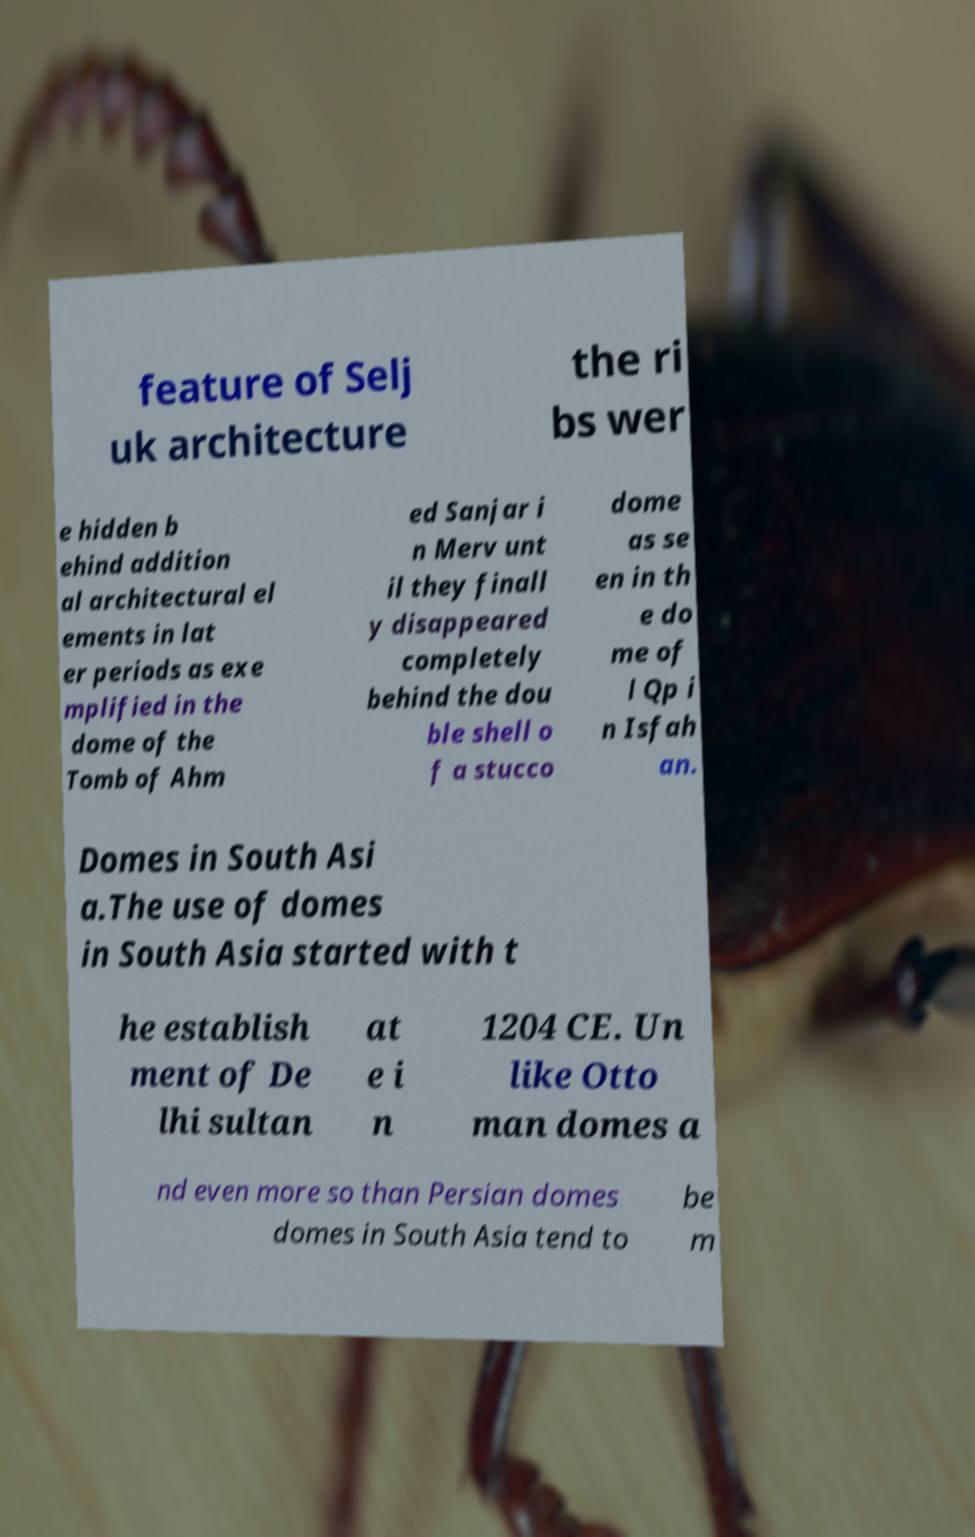Can you accurately transcribe the text from the provided image for me? feature of Selj uk architecture the ri bs wer e hidden b ehind addition al architectural el ements in lat er periods as exe mplified in the dome of the Tomb of Ahm ed Sanjar i n Merv unt il they finall y disappeared completely behind the dou ble shell o f a stucco dome as se en in th e do me of l Qp i n Isfah an. Domes in South Asi a.The use of domes in South Asia started with t he establish ment of De lhi sultan at e i n 1204 CE. Un like Otto man domes a nd even more so than Persian domes domes in South Asia tend to be m 